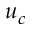Convert formula to latex. <formula><loc_0><loc_0><loc_500><loc_500>u _ { c }</formula> 